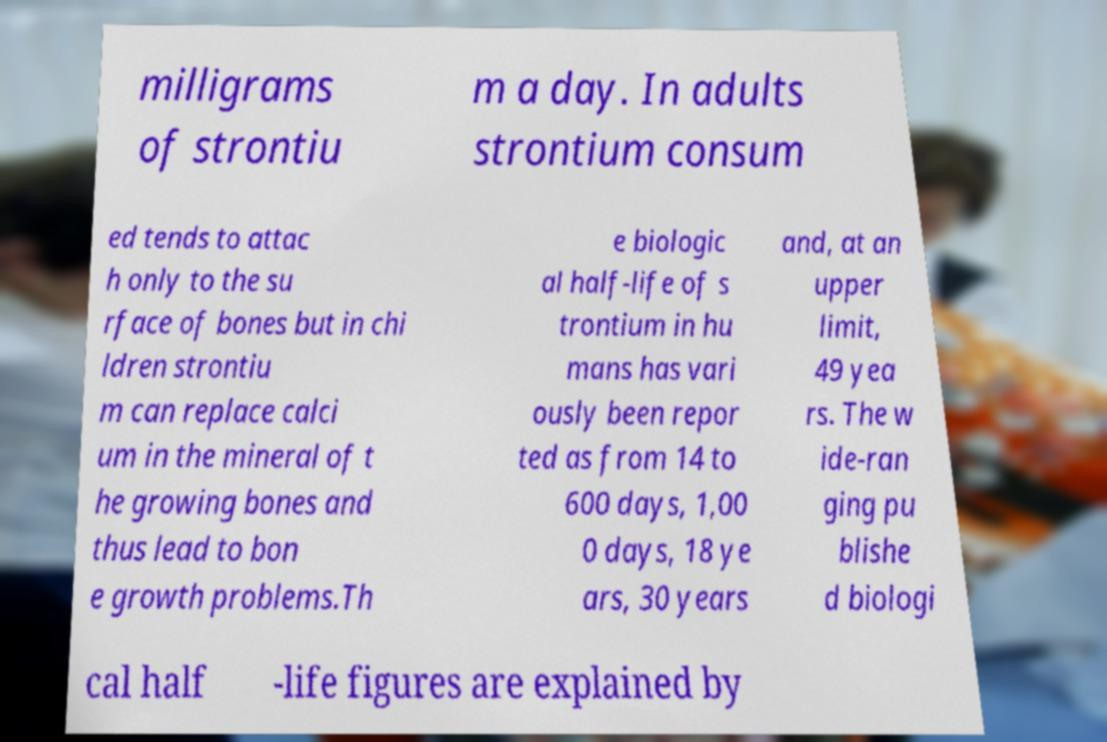Please read and relay the text visible in this image. What does it say? milligrams of strontiu m a day. In adults strontium consum ed tends to attac h only to the su rface of bones but in chi ldren strontiu m can replace calci um in the mineral of t he growing bones and thus lead to bon e growth problems.Th e biologic al half-life of s trontium in hu mans has vari ously been repor ted as from 14 to 600 days, 1,00 0 days, 18 ye ars, 30 years and, at an upper limit, 49 yea rs. The w ide-ran ging pu blishe d biologi cal half -life figures are explained by 